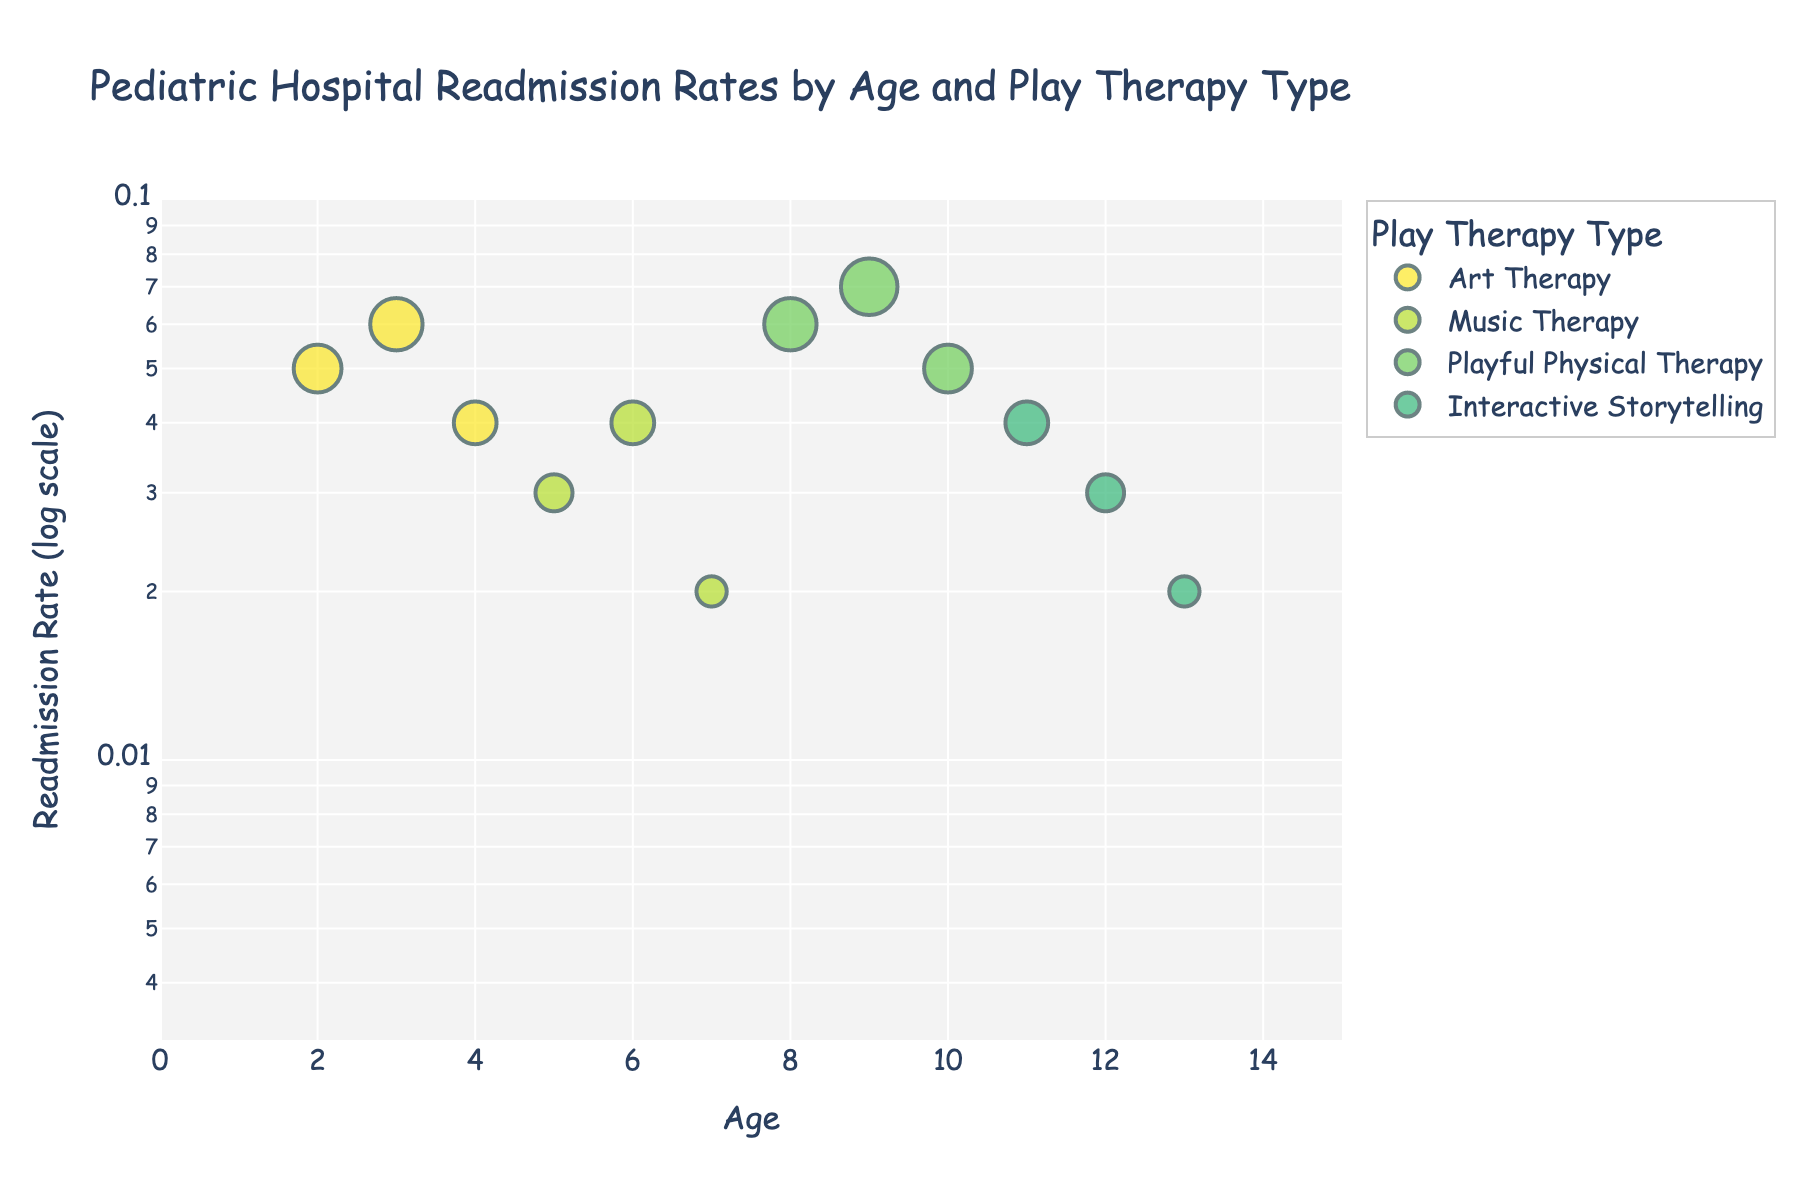what is the title of the scatter plot? The title is located at the top of the scatter plot, indicating what the chart is about. It describes the main subjects of the plot, which are the pediatric hospital readmission rates by age and play therapy type.
Answer: Pediatric Hospital Readmission Rates by Age and Play Therapy Type Which play therapy type shows the highest readmission rate for pediatric patients? By observing the y-axis values (Readmission Rate) and the colors representing different therapy types, the highest point in terms of readmission rate can be identified.
Answer: Playful Physical Therapy What is the lowest readmission rate recorded among all the play therapy types? Look at the lowest point on the y-axis labeled "Readmission Rate" for the scatter plot, regardless of color coding.
Answer: 0.02 How does the readmission rate for Art Therapy change with age? Review the data points specifically colored for Art Therapy and observe the trend as age increases from 2 to 4.
Answer: Decreases from 0.05 to 0.04 At what age does Playful Physical Therapy have the highest readmission rate? Observe the Playful Physical Therapy points and compare the readmission rates for ages 8, 9, and 10. Identify which age has the highest value.
Answer: Age 9 Is there a visible trend in readmission rates related to age based on the scatter plot? Analyze the pattern or trend lines of the data points across all therapy types as age increases.
Answer: Generally decreases with age Which therapy type has the most significant variability in readmission rates? Compare the range (difference between highest and lowest points) of readmission rates for each play therapy type.
Answer: Playful Physical Therapy 